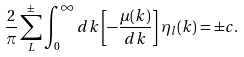Convert formula to latex. <formula><loc_0><loc_0><loc_500><loc_500>\frac { 2 } { \pi } \sum _ { L } ^ { \pm } \int _ { 0 } ^ { \infty } d k \left [ - \frac { \mu ( k ) } { d k } \right ] \eta _ { l } ( k ) = \pm c .</formula> 